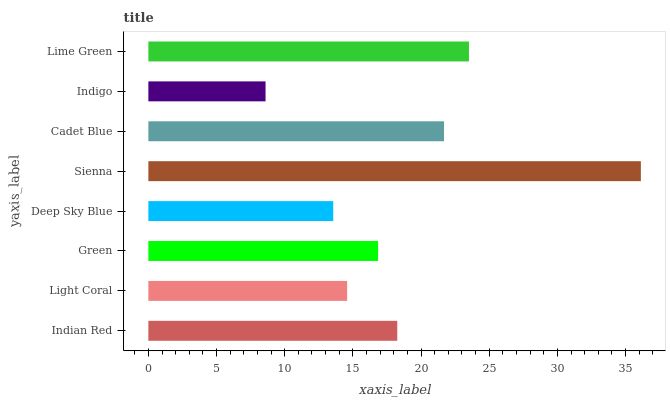Is Indigo the minimum?
Answer yes or no. Yes. Is Sienna the maximum?
Answer yes or no. Yes. Is Light Coral the minimum?
Answer yes or no. No. Is Light Coral the maximum?
Answer yes or no. No. Is Indian Red greater than Light Coral?
Answer yes or no. Yes. Is Light Coral less than Indian Red?
Answer yes or no. Yes. Is Light Coral greater than Indian Red?
Answer yes or no. No. Is Indian Red less than Light Coral?
Answer yes or no. No. Is Indian Red the high median?
Answer yes or no. Yes. Is Green the low median?
Answer yes or no. Yes. Is Light Coral the high median?
Answer yes or no. No. Is Lime Green the low median?
Answer yes or no. No. 